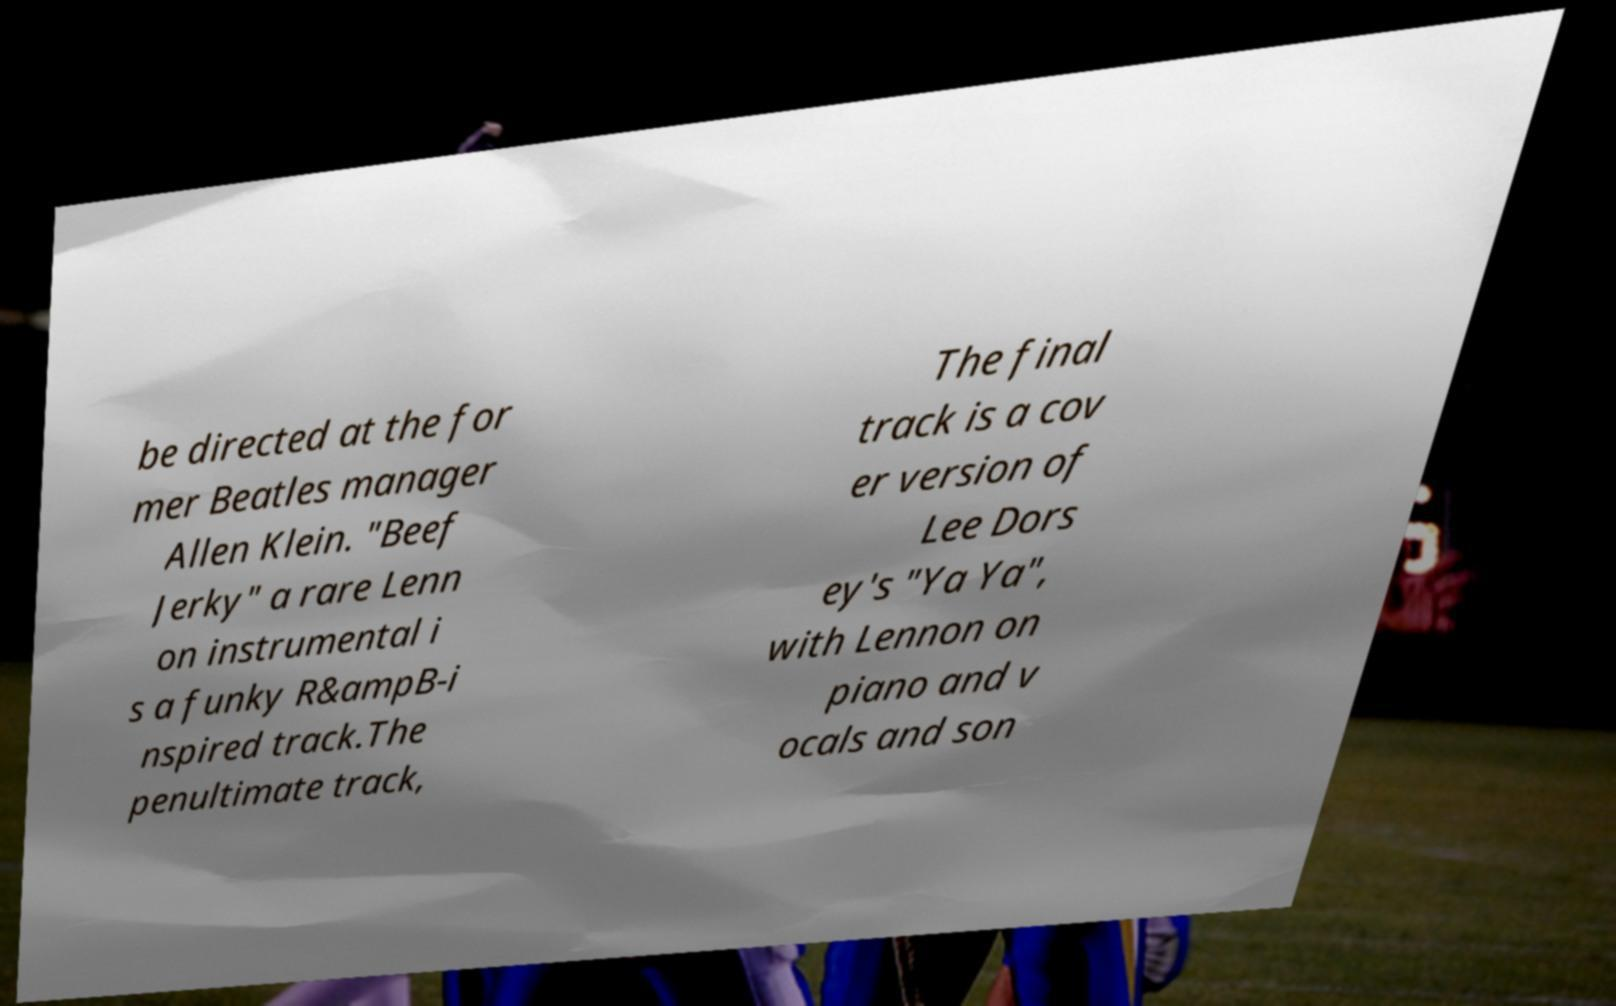Could you extract and type out the text from this image? be directed at the for mer Beatles manager Allen Klein. "Beef Jerky" a rare Lenn on instrumental i s a funky R&ampB-i nspired track.The penultimate track, The final track is a cov er version of Lee Dors ey's "Ya Ya", with Lennon on piano and v ocals and son 